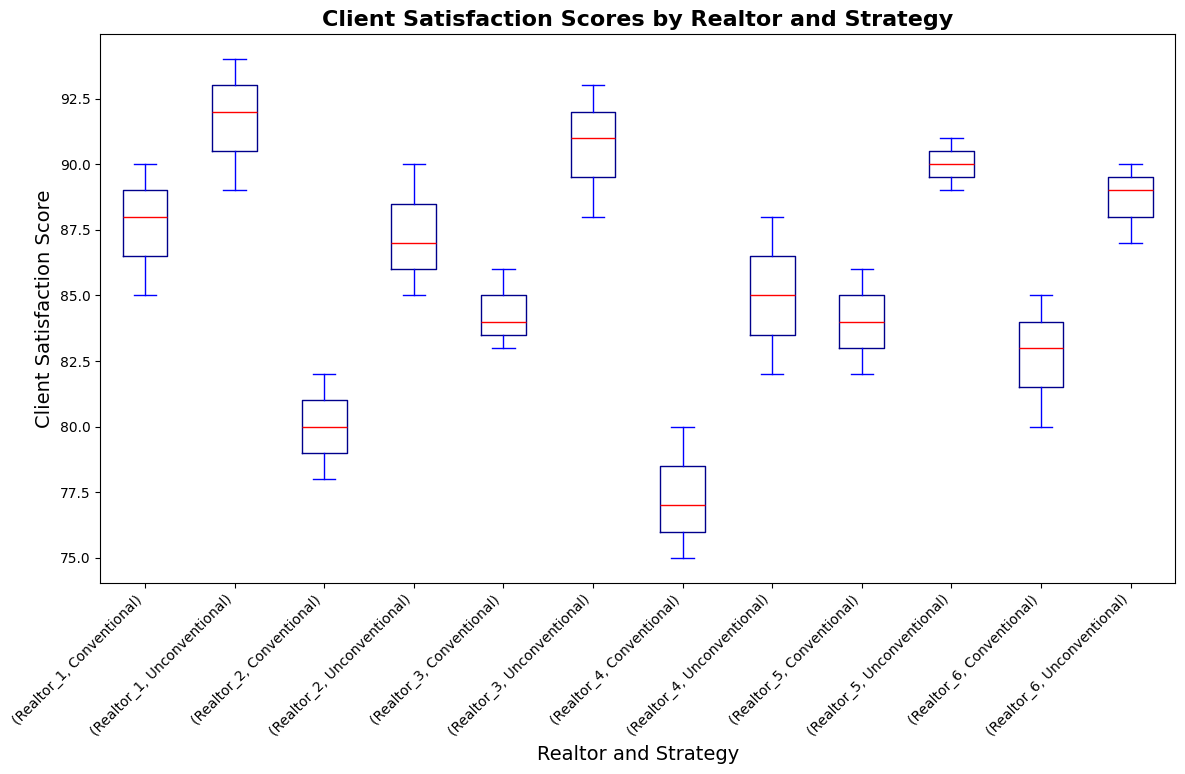What is the median Client Satisfaction Score for Realtor_1 using the Conventional strategy? To find the median score for Realtor_1 with the Conventional strategy, look at the boxplot for Realtor_1 under the Conventional strategy grouping and locate the red line within the box, which represents the median.
Answer: 88 Which realtor has the highest median Client Satisfaction Score using the Unconventional strategy? Identify the median values for the Unconventional strategy for all realtors by locating the red lines within the boxplots for each realtor under the Unconventional strategy grouping, and compare these values to find the highest one.
Answer: Realtor_1 Based on the color of the boxes, how can you distinguish between the whiskers, median, and fliers? The plot uses different colors to indicate different elements: the boxes are dark blue, the whiskers and caps are blue, the median lines are red, and the fliers (outliers) are green.
Answer: Dark blue for boxes, blue for whiskers and caps, red for median, green for fliers Compare the range of satisfaction scores for Realtor_2 using both Conventional and Unconventional strategies. Look at the length of the whiskers for Realtor_2’s Conventional and Unconventional strategies. The Conventional strategy box shows a smaller range, while the Unconventional strategy box and whiskers show a wider range.
Answer: Conventional has a smaller range, Unconventional has a wider range Between Realtor_3 and Realtor_6, who displays a more significant difference in median satisfaction scores when comparing Conventional to Unconventional strategies? Compare the vertical red lines (median) for Conventional and Unconventional strategies within both Realtor_3 and Realtor_6's boxplots. Identify which realtor shows a more significant difference.
Answer: Realtor_3 What can you infer from the height of the boxes for Realtor_4 using both strategies? The height of the boxes (Interquartile Range, IQR) for Realtor_4 using both Conventional and Unconventional strategies is roughly similar, with the Unconventional strategy's box being slightly taller, indicating a slightly greater variability.
Answer: The Unconventional strategy shows slightly greater variability How do the median satisfaction scores for all realtors using the Conventional strategy compare? Look at the red lines (median) within each box for the Conventional strategy for all realtors and compare their vertical positions. Identify which realtor has the highest and lowest median scores.
Answer: Realtor_1 has the highest, Realtor_4 has the lowest What is the interquartile range (IQR) for Realtor_5’s satisfaction scores using the Unconventional strategy? The IQR is the difference between the third quartile (top edge of the box) and the first quartile (bottom edge of the box) for Realtor_5’s Unconventional boxplot. Identify the values on the y-axis corresponding to these edges.
Answer: Approximately 2 (91 - 89), you need to look at the accurate values in the box Is there an outlier in the satisfaction scores for any realtor? Outliers are depicted as green markers outside the whisker range. Scan the boxplots to identify any green markers.
Answer: No Which realtor shows the most significant improvement in median scores when using Unconventional strategies over Conventional ones? Compare the vertical red lines (median) for Conventional and Unconventional strategies for each realtor. Identify the difference for each and determine which has the most significant improvement.
Answer: Realtor_2 